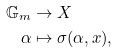<formula> <loc_0><loc_0><loc_500><loc_500>\mathbb { G } _ { m } & \to X \\ \alpha & \mapsto \sigma ( \alpha , x ) ,</formula> 